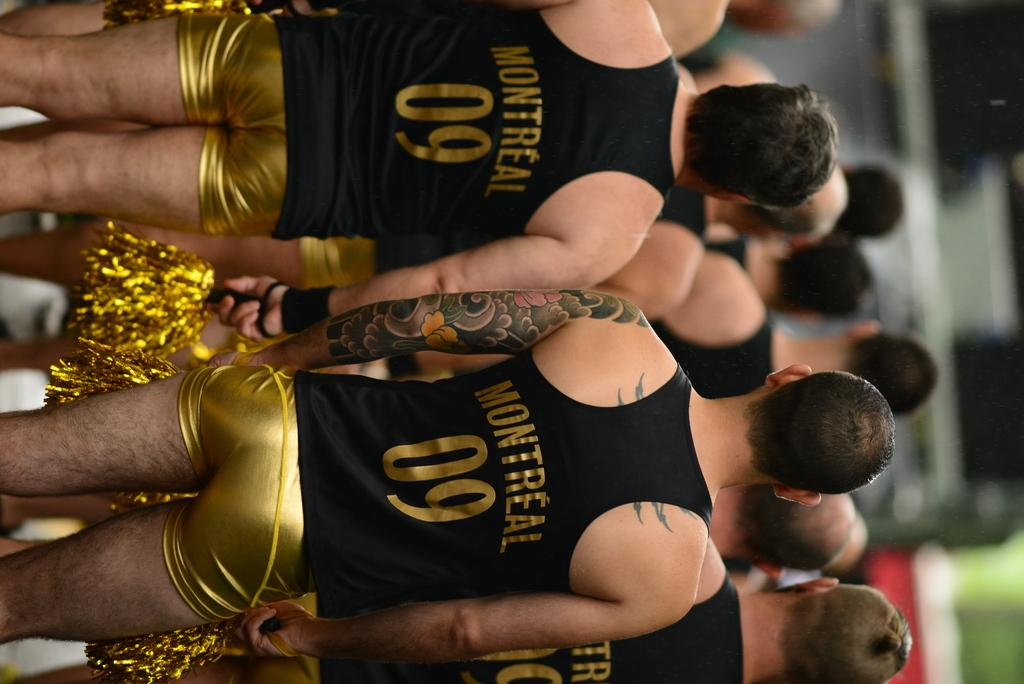What is the main subject of the image? The main subject of the image is a group of people. What are the people in the image doing? The people are standing. What colors are the people wearing in the image? The people are wearing black and gold color dress. What are the people holding in their hands in the image? The people are holding something in their hands. What type of brain can be seen in the image? There is no brain visible in the image. 